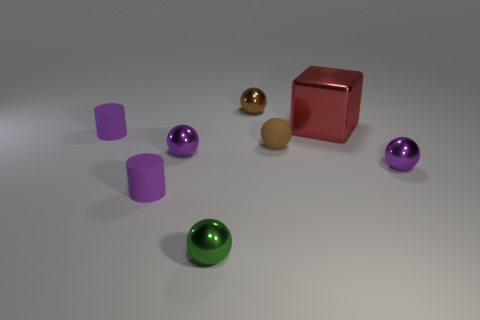Subtract all brown balls. How many balls are left? 3 Subtract 2 balls. How many balls are left? 3 Subtract all brown balls. How many balls are left? 3 Add 1 blocks. How many objects exist? 9 Subtract all cyan spheres. Subtract all cyan cubes. How many spheres are left? 5 Subtract all cylinders. How many objects are left? 6 Add 4 brown shiny balls. How many brown shiny balls exist? 5 Subtract 0 green cylinders. How many objects are left? 8 Subtract all tiny metal spheres. Subtract all big green objects. How many objects are left? 4 Add 4 rubber cylinders. How many rubber cylinders are left? 6 